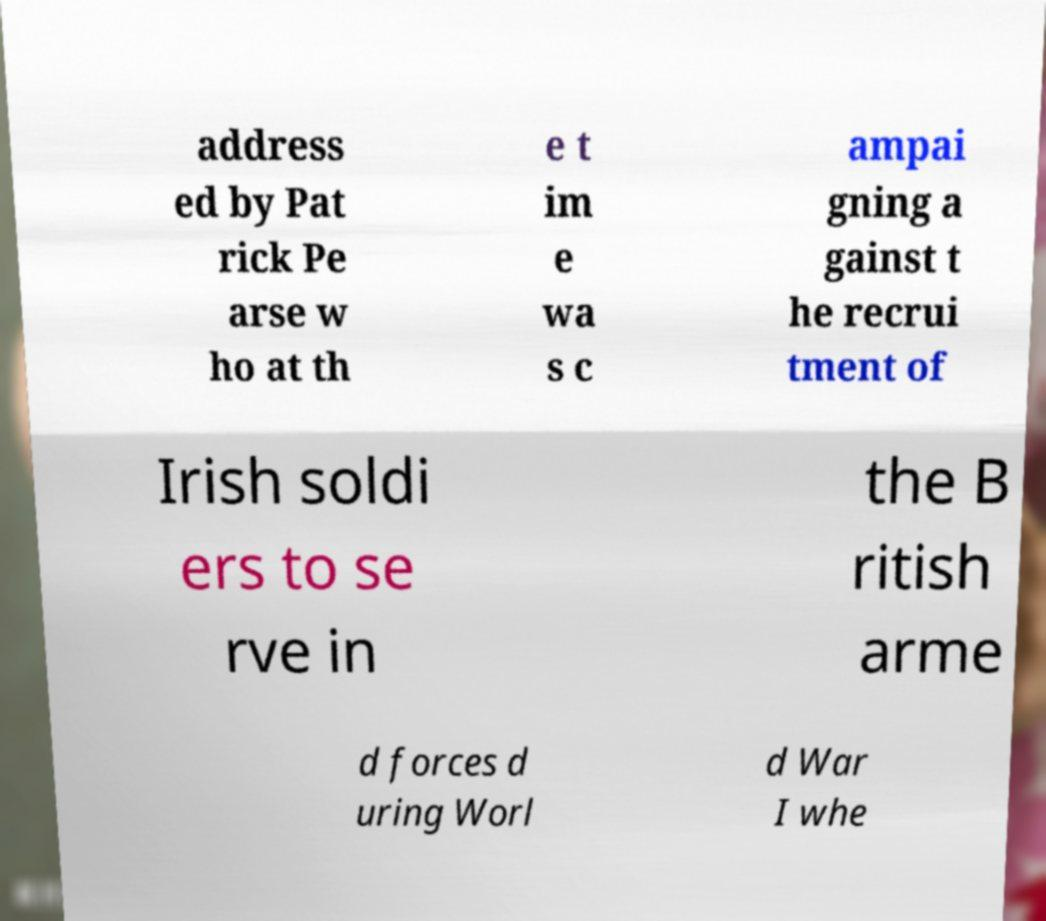Can you read and provide the text displayed in the image?This photo seems to have some interesting text. Can you extract and type it out for me? address ed by Pat rick Pe arse w ho at th e t im e wa s c ampai gning a gainst t he recrui tment of Irish soldi ers to se rve in the B ritish arme d forces d uring Worl d War I whe 